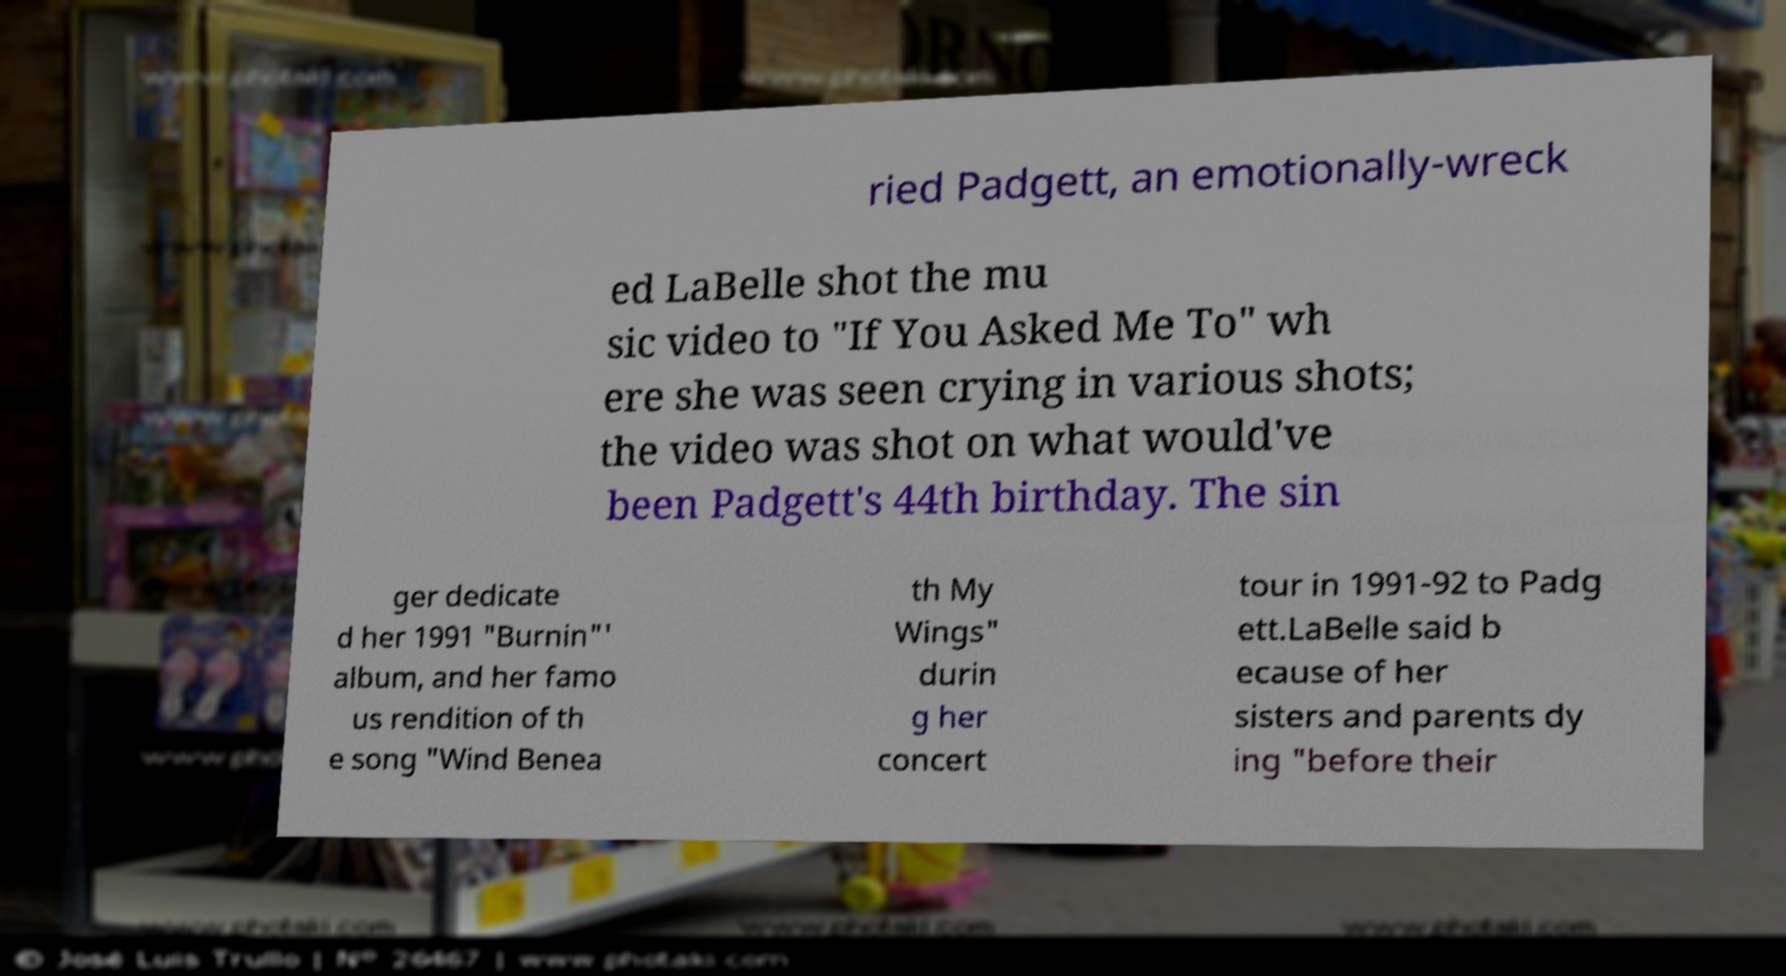For documentation purposes, I need the text within this image transcribed. Could you provide that? ried Padgett, an emotionally-wreck ed LaBelle shot the mu sic video to "If You Asked Me To" wh ere she was seen crying in various shots; the video was shot on what would've been Padgett's 44th birthday. The sin ger dedicate d her 1991 "Burnin"' album, and her famo us rendition of th e song "Wind Benea th My Wings" durin g her concert tour in 1991-92 to Padg ett.LaBelle said b ecause of her sisters and parents dy ing "before their 